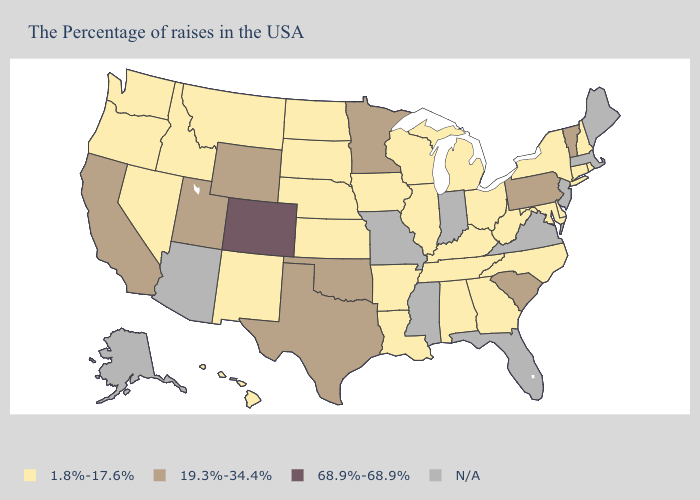Does Arkansas have the highest value in the South?
Give a very brief answer. No. Which states have the highest value in the USA?
Give a very brief answer. Colorado. What is the lowest value in the USA?
Answer briefly. 1.8%-17.6%. Name the states that have a value in the range 19.3%-34.4%?
Quick response, please. Vermont, Pennsylvania, South Carolina, Minnesota, Oklahoma, Texas, Wyoming, Utah, California. Name the states that have a value in the range 19.3%-34.4%?
Short answer required. Vermont, Pennsylvania, South Carolina, Minnesota, Oklahoma, Texas, Wyoming, Utah, California. Which states have the highest value in the USA?
Short answer required. Colorado. Which states have the lowest value in the USA?
Concise answer only. Rhode Island, New Hampshire, Connecticut, New York, Delaware, Maryland, North Carolina, West Virginia, Ohio, Georgia, Michigan, Kentucky, Alabama, Tennessee, Wisconsin, Illinois, Louisiana, Arkansas, Iowa, Kansas, Nebraska, South Dakota, North Dakota, New Mexico, Montana, Idaho, Nevada, Washington, Oregon, Hawaii. What is the lowest value in the USA?
Concise answer only. 1.8%-17.6%. What is the highest value in the USA?
Concise answer only. 68.9%-68.9%. What is the value of Oregon?
Answer briefly. 1.8%-17.6%. What is the lowest value in states that border Oklahoma?
Keep it brief. 1.8%-17.6%. What is the value of Kentucky?
Concise answer only. 1.8%-17.6%. Does Michigan have the highest value in the USA?
Concise answer only. No. What is the value of Pennsylvania?
Be succinct. 19.3%-34.4%. Name the states that have a value in the range 19.3%-34.4%?
Write a very short answer. Vermont, Pennsylvania, South Carolina, Minnesota, Oklahoma, Texas, Wyoming, Utah, California. 